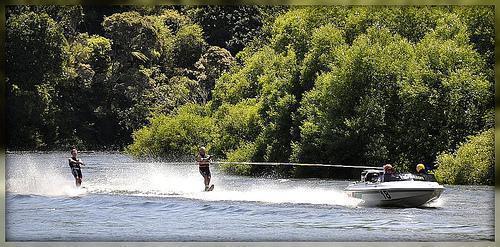What are the two doing behind the boat?
Indicate the correct choice and explain in the format: 'Answer: answer
Rationale: rationale.'
Options: Diving, swimming, fishing, water skiing. Answer: water skiing.
Rationale: The people are skiing in the water. 